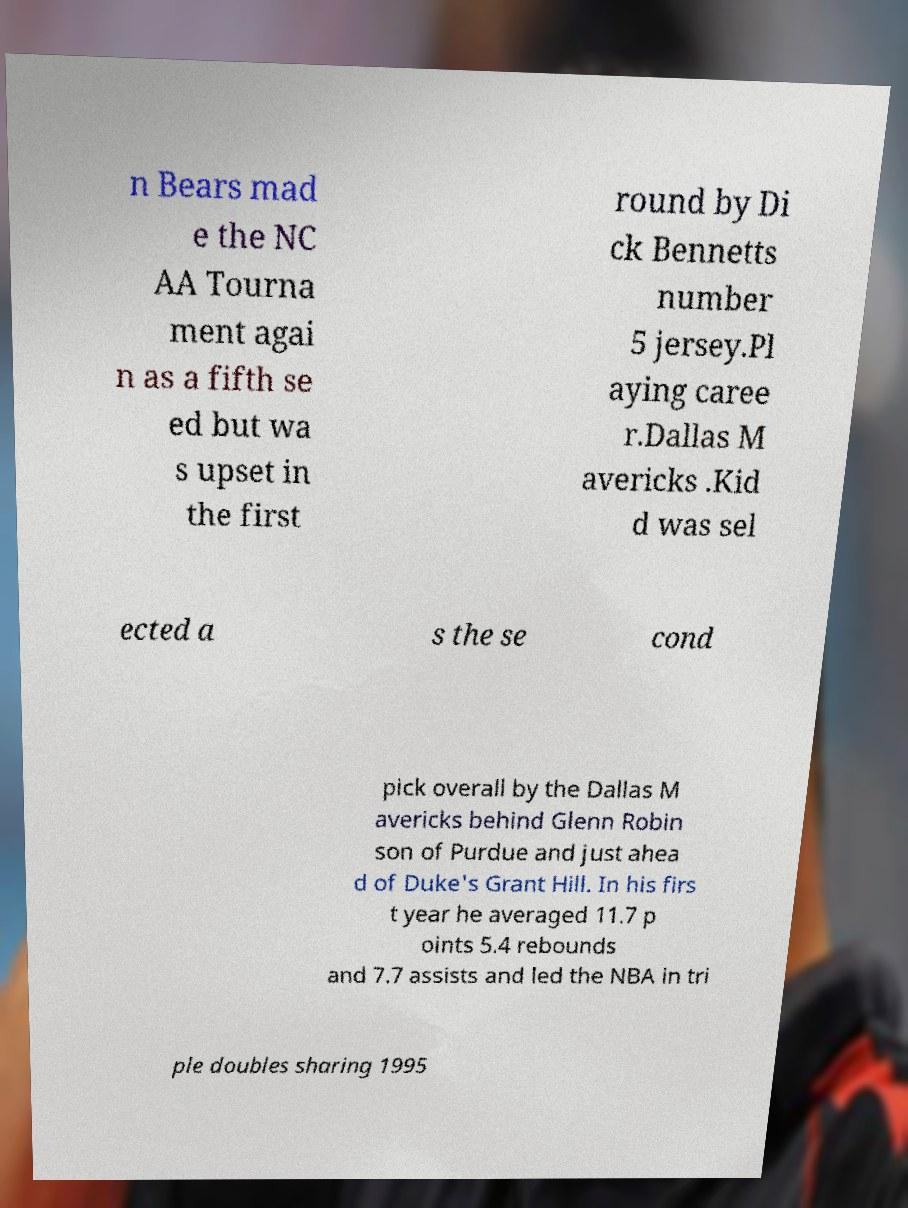Please read and relay the text visible in this image. What does it say? n Bears mad e the NC AA Tourna ment agai n as a fifth se ed but wa s upset in the first round by Di ck Bennetts number 5 jersey.Pl aying caree r.Dallas M avericks .Kid d was sel ected a s the se cond pick overall by the Dallas M avericks behind Glenn Robin son of Purdue and just ahea d of Duke's Grant Hill. In his firs t year he averaged 11.7 p oints 5.4 rebounds and 7.7 assists and led the NBA in tri ple doubles sharing 1995 